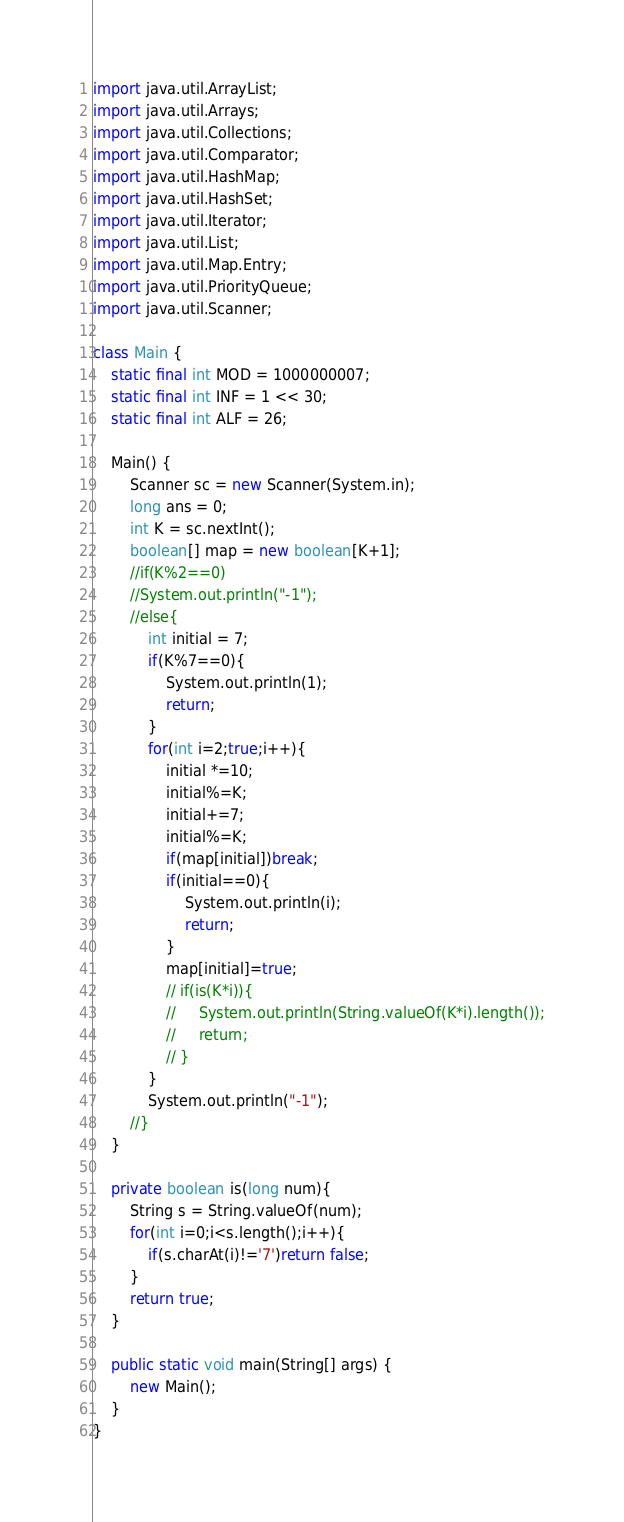<code> <loc_0><loc_0><loc_500><loc_500><_Java_>import java.util.ArrayList;
import java.util.Arrays;
import java.util.Collections;
import java.util.Comparator;
import java.util.HashMap;
import java.util.HashSet;
import java.util.Iterator;
import java.util.List;
import java.util.Map.Entry;
import java.util.PriorityQueue;
import java.util.Scanner;

class Main {
    static final int MOD = 1000000007;
    static final int INF = 1 << 30;
    static final int ALF = 26;

    Main() {
        Scanner sc = new Scanner(System.in);
        long ans = 0;
        int K = sc.nextInt();
        boolean[] map = new boolean[K+1];
        //if(K%2==0)
        //System.out.println("-1");
        //else{
            int initial = 7;
            if(K%7==0){
                System.out.println(1);
                return;
            }
            for(int i=2;true;i++){
                initial *=10;
                initial%=K;
                initial+=7;
                initial%=K;
                if(map[initial])break;
                if(initial==0){
                    System.out.println(i);
                    return;
                }
                map[initial]=true;
                // if(is(K*i)){
                //     System.out.println(String.valueOf(K*i).length());
                //     return;
                // }
            }
            System.out.println("-1");
        //}
    }

    private boolean is(long num){
        String s = String.valueOf(num);
        for(int i=0;i<s.length();i++){
            if(s.charAt(i)!='7')return false;
        }
        return true;
    }

    public static void main(String[] args) {
        new Main();
    }
}
</code> 